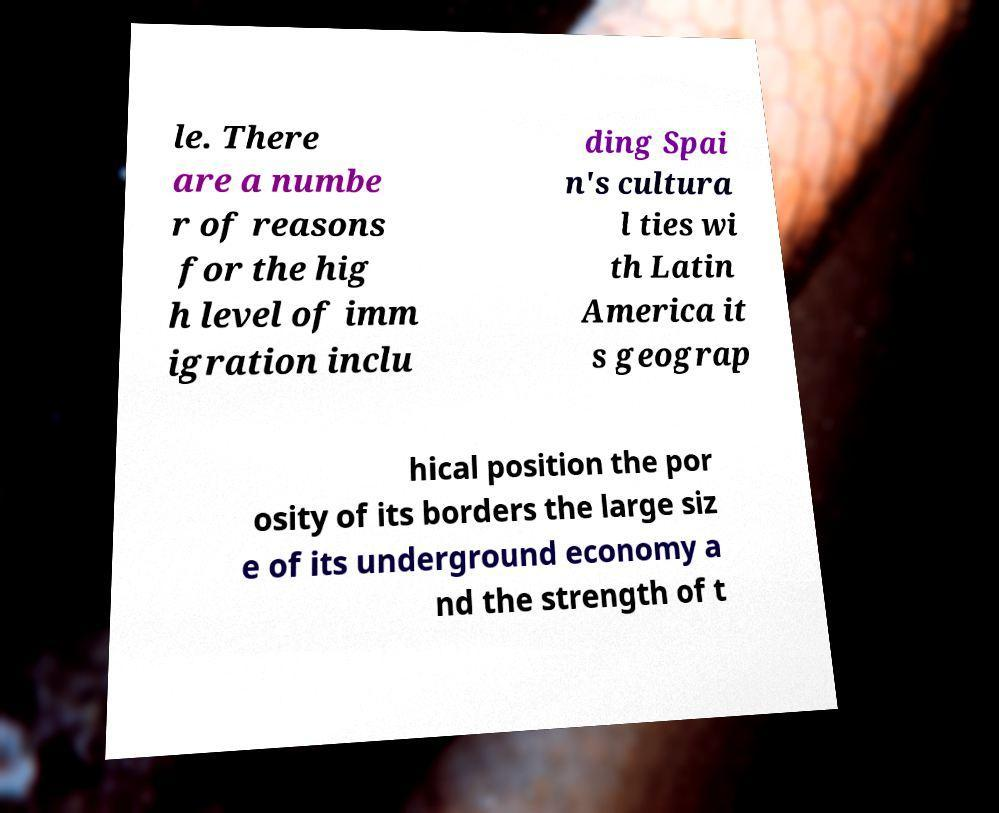Could you assist in decoding the text presented in this image and type it out clearly? le. There are a numbe r of reasons for the hig h level of imm igration inclu ding Spai n's cultura l ties wi th Latin America it s geograp hical position the por osity of its borders the large siz e of its underground economy a nd the strength of t 